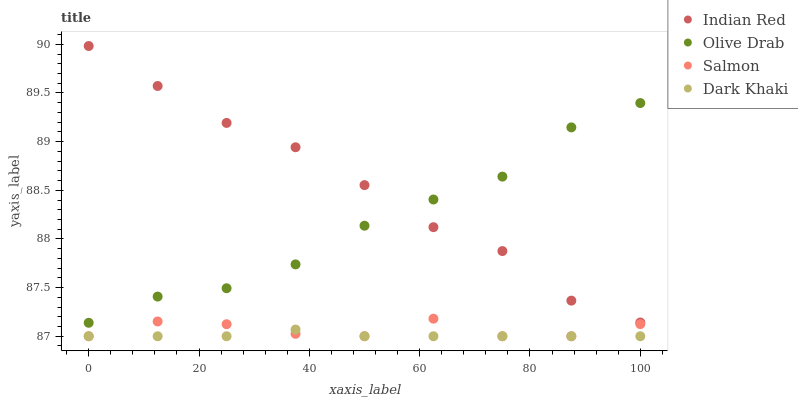Does Dark Khaki have the minimum area under the curve?
Answer yes or no. Yes. Does Indian Red have the maximum area under the curve?
Answer yes or no. Yes. Does Salmon have the minimum area under the curve?
Answer yes or no. No. Does Salmon have the maximum area under the curve?
Answer yes or no. No. Is Dark Khaki the smoothest?
Answer yes or no. Yes. Is Salmon the roughest?
Answer yes or no. Yes. Is Olive Drab the smoothest?
Answer yes or no. No. Is Olive Drab the roughest?
Answer yes or no. No. Does Dark Khaki have the lowest value?
Answer yes or no. Yes. Does Olive Drab have the lowest value?
Answer yes or no. No. Does Indian Red have the highest value?
Answer yes or no. Yes. Does Salmon have the highest value?
Answer yes or no. No. Is Dark Khaki less than Indian Red?
Answer yes or no. Yes. Is Olive Drab greater than Dark Khaki?
Answer yes or no. Yes. Does Salmon intersect Dark Khaki?
Answer yes or no. Yes. Is Salmon less than Dark Khaki?
Answer yes or no. No. Is Salmon greater than Dark Khaki?
Answer yes or no. No. Does Dark Khaki intersect Indian Red?
Answer yes or no. No. 